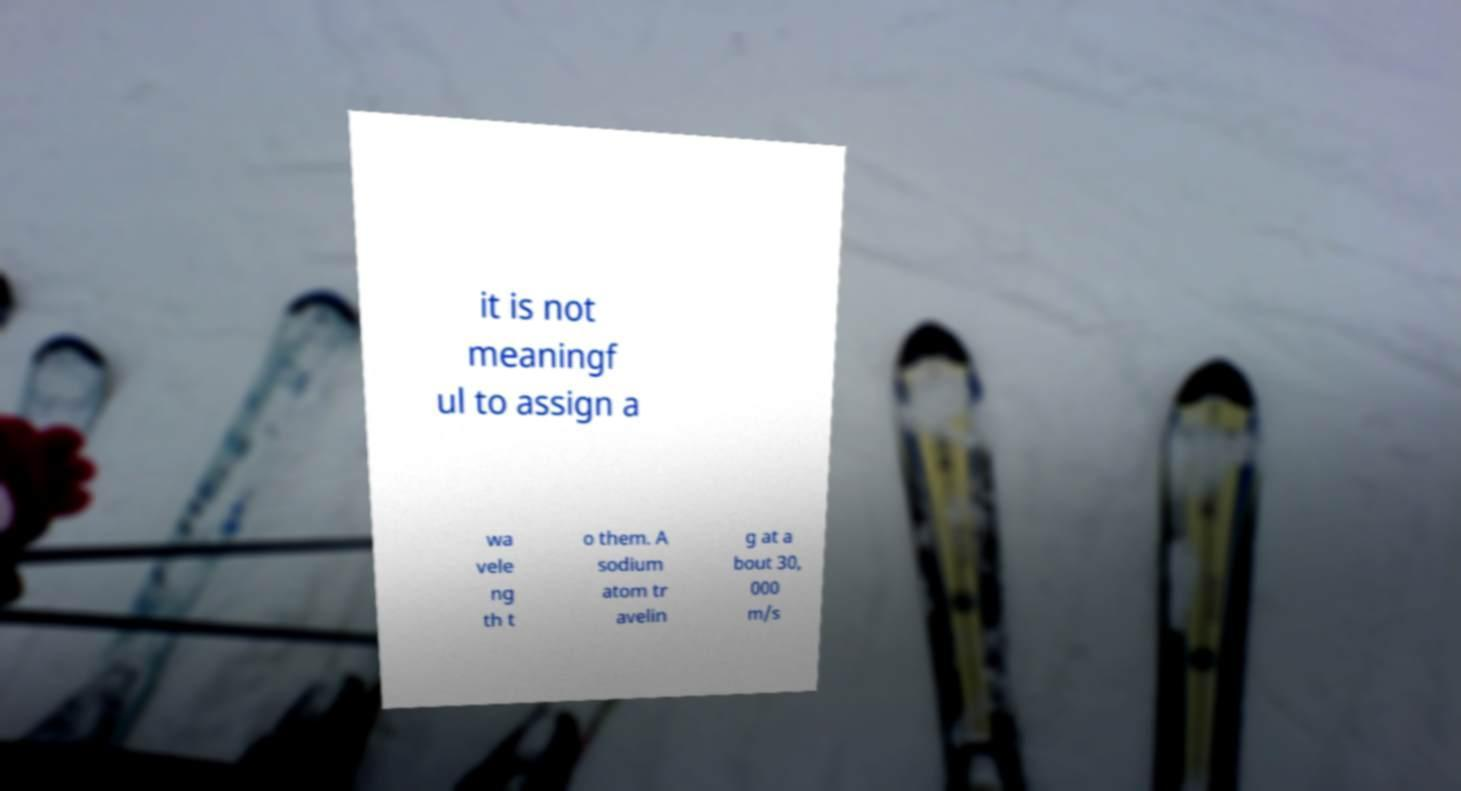Please identify and transcribe the text found in this image. it is not meaningf ul to assign a wa vele ng th t o them. A sodium atom tr avelin g at a bout 30, 000 m/s 